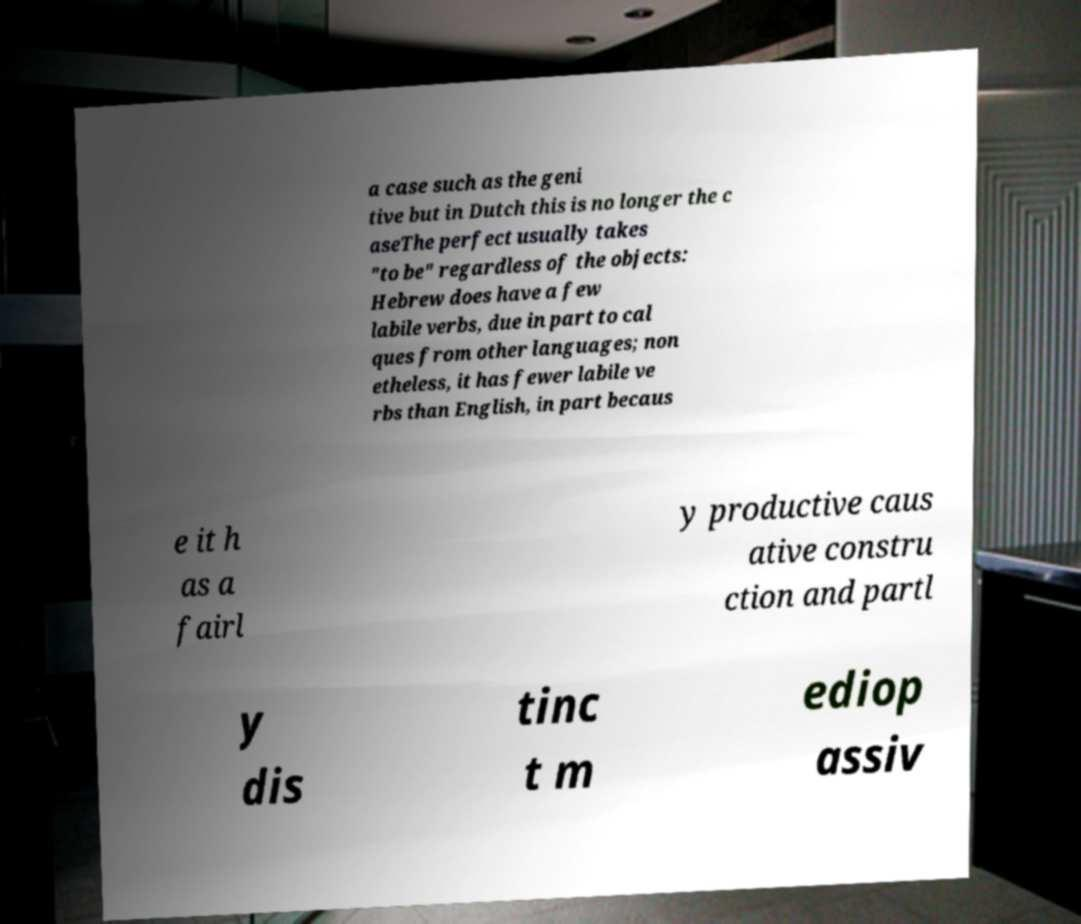Can you read and provide the text displayed in the image?This photo seems to have some interesting text. Can you extract and type it out for me? a case such as the geni tive but in Dutch this is no longer the c aseThe perfect usually takes "to be" regardless of the objects: Hebrew does have a few labile verbs, due in part to cal ques from other languages; non etheless, it has fewer labile ve rbs than English, in part becaus e it h as a fairl y productive caus ative constru ction and partl y dis tinc t m ediop assiv 